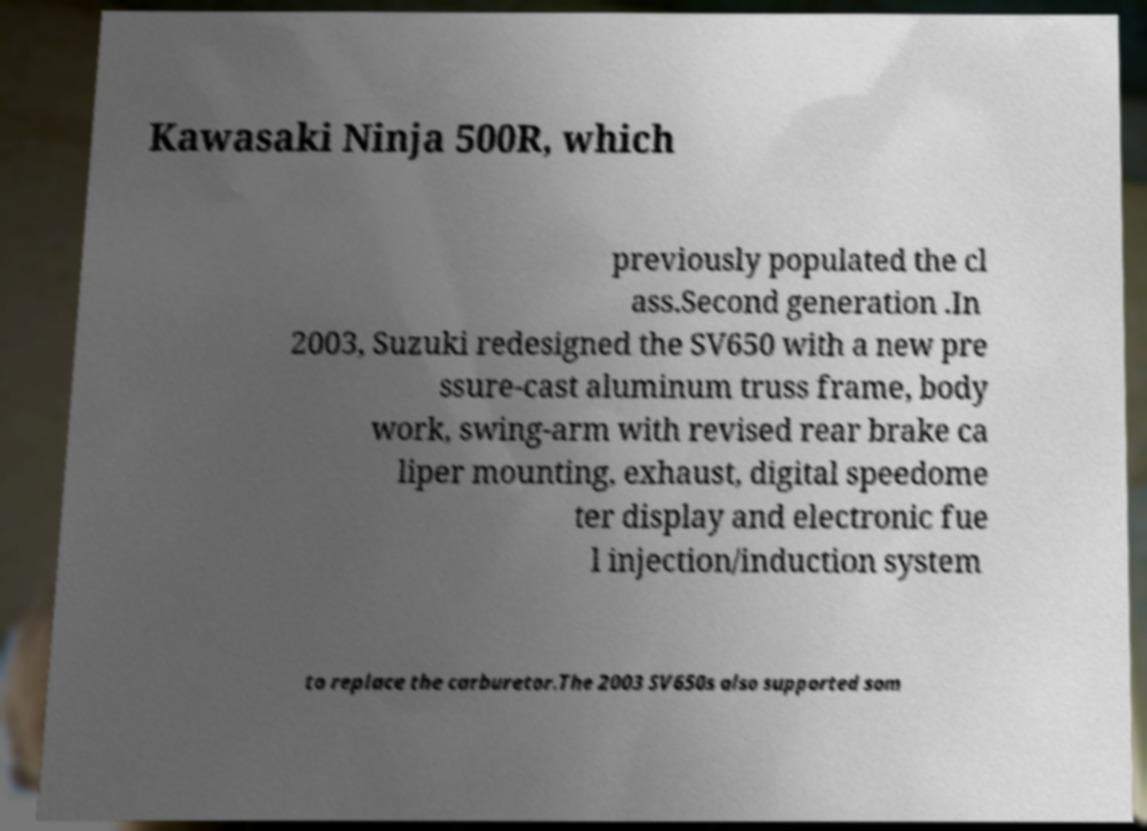Could you extract and type out the text from this image? Kawasaki Ninja 500R, which previously populated the cl ass.Second generation .In 2003, Suzuki redesigned the SV650 with a new pre ssure-cast aluminum truss frame, body work, swing-arm with revised rear brake ca liper mounting, exhaust, digital speedome ter display and electronic fue l injection/induction system to replace the carburetor.The 2003 SV650s also supported som 